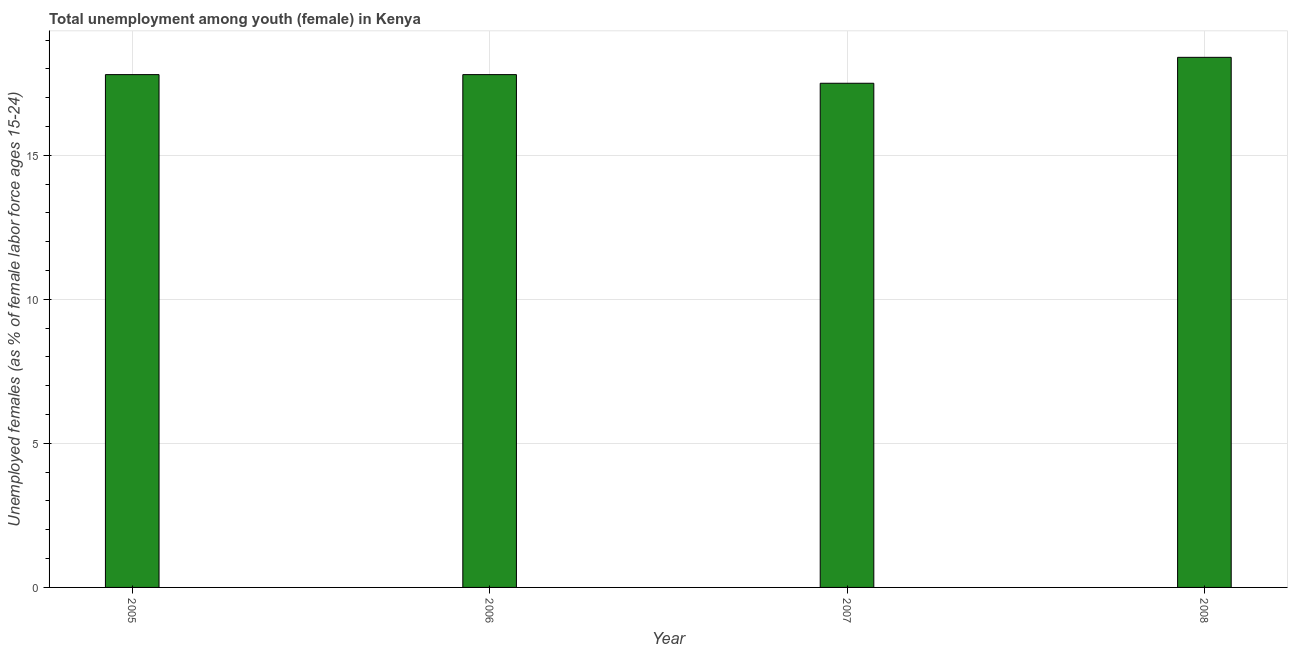Does the graph contain grids?
Your answer should be compact. Yes. What is the title of the graph?
Give a very brief answer. Total unemployment among youth (female) in Kenya. What is the label or title of the Y-axis?
Keep it short and to the point. Unemployed females (as % of female labor force ages 15-24). What is the unemployed female youth population in 2006?
Provide a succinct answer. 17.8. Across all years, what is the maximum unemployed female youth population?
Give a very brief answer. 18.4. In which year was the unemployed female youth population maximum?
Give a very brief answer. 2008. In which year was the unemployed female youth population minimum?
Your answer should be very brief. 2007. What is the sum of the unemployed female youth population?
Offer a very short reply. 71.5. What is the average unemployed female youth population per year?
Your response must be concise. 17.88. What is the median unemployed female youth population?
Offer a terse response. 17.8. In how many years, is the unemployed female youth population greater than 15 %?
Offer a terse response. 4. Do a majority of the years between 2008 and 2006 (inclusive) have unemployed female youth population greater than 11 %?
Give a very brief answer. Yes. Is the sum of the unemployed female youth population in 2007 and 2008 greater than the maximum unemployed female youth population across all years?
Ensure brevity in your answer.  Yes. In how many years, is the unemployed female youth population greater than the average unemployed female youth population taken over all years?
Offer a terse response. 1. How many bars are there?
Your answer should be very brief. 4. How many years are there in the graph?
Provide a short and direct response. 4. What is the difference between two consecutive major ticks on the Y-axis?
Keep it short and to the point. 5. What is the Unemployed females (as % of female labor force ages 15-24) of 2005?
Provide a succinct answer. 17.8. What is the Unemployed females (as % of female labor force ages 15-24) of 2006?
Provide a succinct answer. 17.8. What is the Unemployed females (as % of female labor force ages 15-24) of 2008?
Keep it short and to the point. 18.4. What is the difference between the Unemployed females (as % of female labor force ages 15-24) in 2005 and 2006?
Your answer should be compact. 0. What is the difference between the Unemployed females (as % of female labor force ages 15-24) in 2005 and 2007?
Provide a succinct answer. 0.3. What is the difference between the Unemployed females (as % of female labor force ages 15-24) in 2005 and 2008?
Provide a short and direct response. -0.6. What is the difference between the Unemployed females (as % of female labor force ages 15-24) in 2006 and 2007?
Offer a very short reply. 0.3. What is the difference between the Unemployed females (as % of female labor force ages 15-24) in 2006 and 2008?
Your answer should be very brief. -0.6. What is the difference between the Unemployed females (as % of female labor force ages 15-24) in 2007 and 2008?
Ensure brevity in your answer.  -0.9. What is the ratio of the Unemployed females (as % of female labor force ages 15-24) in 2005 to that in 2007?
Keep it short and to the point. 1.02. What is the ratio of the Unemployed females (as % of female labor force ages 15-24) in 2005 to that in 2008?
Your response must be concise. 0.97. What is the ratio of the Unemployed females (as % of female labor force ages 15-24) in 2006 to that in 2007?
Provide a short and direct response. 1.02. What is the ratio of the Unemployed females (as % of female labor force ages 15-24) in 2006 to that in 2008?
Provide a succinct answer. 0.97. What is the ratio of the Unemployed females (as % of female labor force ages 15-24) in 2007 to that in 2008?
Make the answer very short. 0.95. 